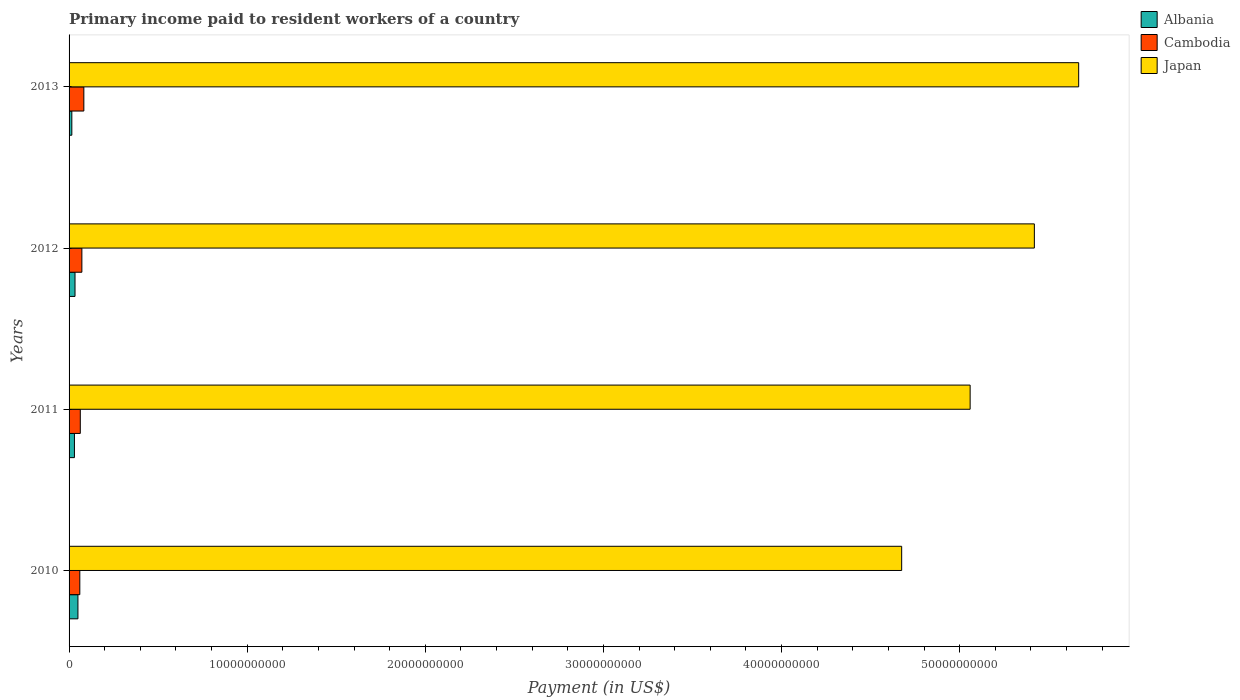Are the number of bars on each tick of the Y-axis equal?
Ensure brevity in your answer.  Yes. In how many cases, is the number of bars for a given year not equal to the number of legend labels?
Your answer should be very brief. 0. What is the amount paid to workers in Japan in 2013?
Provide a succinct answer. 5.67e+1. Across all years, what is the maximum amount paid to workers in Cambodia?
Keep it short and to the point. 8.29e+08. Across all years, what is the minimum amount paid to workers in Japan?
Make the answer very short. 4.67e+1. In which year was the amount paid to workers in Japan maximum?
Offer a very short reply. 2013. In which year was the amount paid to workers in Albania minimum?
Offer a very short reply. 2013. What is the total amount paid to workers in Albania in the graph?
Your answer should be compact. 1.29e+09. What is the difference between the amount paid to workers in Albania in 2010 and that in 2012?
Make the answer very short. 1.64e+08. What is the difference between the amount paid to workers in Japan in 2013 and the amount paid to workers in Albania in 2012?
Make the answer very short. 5.63e+1. What is the average amount paid to workers in Cambodia per year?
Ensure brevity in your answer.  6.95e+08. In the year 2012, what is the difference between the amount paid to workers in Albania and amount paid to workers in Cambodia?
Provide a succinct answer. -3.85e+08. What is the ratio of the amount paid to workers in Albania in 2011 to that in 2013?
Make the answer very short. 1.95. What is the difference between the highest and the second highest amount paid to workers in Cambodia?
Make the answer very short. 1.10e+08. What is the difference between the highest and the lowest amount paid to workers in Japan?
Make the answer very short. 9.94e+09. In how many years, is the amount paid to workers in Albania greater than the average amount paid to workers in Albania taken over all years?
Your response must be concise. 2. Is the sum of the amount paid to workers in Albania in 2010 and 2013 greater than the maximum amount paid to workers in Japan across all years?
Your answer should be very brief. No. What does the 3rd bar from the top in 2012 represents?
Offer a very short reply. Albania. What does the 3rd bar from the bottom in 2010 represents?
Keep it short and to the point. Japan. Is it the case that in every year, the sum of the amount paid to workers in Albania and amount paid to workers in Japan is greater than the amount paid to workers in Cambodia?
Keep it short and to the point. Yes. Are all the bars in the graph horizontal?
Give a very brief answer. Yes. How many years are there in the graph?
Provide a succinct answer. 4. What is the difference between two consecutive major ticks on the X-axis?
Provide a succinct answer. 1.00e+1. Are the values on the major ticks of X-axis written in scientific E-notation?
Your answer should be compact. No. Does the graph contain grids?
Provide a short and direct response. No. Where does the legend appear in the graph?
Make the answer very short. Top right. What is the title of the graph?
Provide a succinct answer. Primary income paid to resident workers of a country. What is the label or title of the X-axis?
Provide a short and direct response. Payment (in US$). What is the Payment (in US$) in Albania in 2010?
Ensure brevity in your answer.  4.98e+08. What is the Payment (in US$) of Cambodia in 2010?
Your answer should be very brief. 6.03e+08. What is the Payment (in US$) of Japan in 2010?
Provide a short and direct response. 4.67e+1. What is the Payment (in US$) of Albania in 2011?
Give a very brief answer. 3.01e+08. What is the Payment (in US$) of Cambodia in 2011?
Make the answer very short. 6.30e+08. What is the Payment (in US$) in Japan in 2011?
Provide a short and direct response. 5.06e+1. What is the Payment (in US$) of Albania in 2012?
Offer a terse response. 3.34e+08. What is the Payment (in US$) of Cambodia in 2012?
Offer a terse response. 7.19e+08. What is the Payment (in US$) of Japan in 2012?
Ensure brevity in your answer.  5.42e+1. What is the Payment (in US$) of Albania in 2013?
Keep it short and to the point. 1.55e+08. What is the Payment (in US$) in Cambodia in 2013?
Give a very brief answer. 8.29e+08. What is the Payment (in US$) in Japan in 2013?
Give a very brief answer. 5.67e+1. Across all years, what is the maximum Payment (in US$) of Albania?
Provide a succinct answer. 4.98e+08. Across all years, what is the maximum Payment (in US$) in Cambodia?
Your answer should be very brief. 8.29e+08. Across all years, what is the maximum Payment (in US$) in Japan?
Provide a short and direct response. 5.67e+1. Across all years, what is the minimum Payment (in US$) of Albania?
Ensure brevity in your answer.  1.55e+08. Across all years, what is the minimum Payment (in US$) of Cambodia?
Ensure brevity in your answer.  6.03e+08. Across all years, what is the minimum Payment (in US$) in Japan?
Give a very brief answer. 4.67e+1. What is the total Payment (in US$) in Albania in the graph?
Your response must be concise. 1.29e+09. What is the total Payment (in US$) of Cambodia in the graph?
Your response must be concise. 2.78e+09. What is the total Payment (in US$) in Japan in the graph?
Offer a terse response. 2.08e+11. What is the difference between the Payment (in US$) in Albania in 2010 and that in 2011?
Make the answer very short. 1.97e+08. What is the difference between the Payment (in US$) of Cambodia in 2010 and that in 2011?
Your response must be concise. -2.71e+07. What is the difference between the Payment (in US$) in Japan in 2010 and that in 2011?
Offer a terse response. -3.84e+09. What is the difference between the Payment (in US$) of Albania in 2010 and that in 2012?
Your response must be concise. 1.64e+08. What is the difference between the Payment (in US$) of Cambodia in 2010 and that in 2012?
Offer a terse response. -1.16e+08. What is the difference between the Payment (in US$) in Japan in 2010 and that in 2012?
Your response must be concise. -7.45e+09. What is the difference between the Payment (in US$) in Albania in 2010 and that in 2013?
Your answer should be compact. 3.43e+08. What is the difference between the Payment (in US$) in Cambodia in 2010 and that in 2013?
Your answer should be very brief. -2.26e+08. What is the difference between the Payment (in US$) of Japan in 2010 and that in 2013?
Offer a very short reply. -9.94e+09. What is the difference between the Payment (in US$) in Albania in 2011 and that in 2012?
Make the answer very short. -3.30e+07. What is the difference between the Payment (in US$) in Cambodia in 2011 and that in 2012?
Provide a short and direct response. -8.91e+07. What is the difference between the Payment (in US$) of Japan in 2011 and that in 2012?
Your response must be concise. -3.61e+09. What is the difference between the Payment (in US$) of Albania in 2011 and that in 2013?
Your answer should be very brief. 1.46e+08. What is the difference between the Payment (in US$) in Cambodia in 2011 and that in 2013?
Provide a succinct answer. -1.99e+08. What is the difference between the Payment (in US$) of Japan in 2011 and that in 2013?
Keep it short and to the point. -6.09e+09. What is the difference between the Payment (in US$) in Albania in 2012 and that in 2013?
Make the answer very short. 1.79e+08. What is the difference between the Payment (in US$) of Cambodia in 2012 and that in 2013?
Ensure brevity in your answer.  -1.10e+08. What is the difference between the Payment (in US$) in Japan in 2012 and that in 2013?
Your answer should be compact. -2.49e+09. What is the difference between the Payment (in US$) of Albania in 2010 and the Payment (in US$) of Cambodia in 2011?
Ensure brevity in your answer.  -1.32e+08. What is the difference between the Payment (in US$) in Albania in 2010 and the Payment (in US$) in Japan in 2011?
Make the answer very short. -5.01e+1. What is the difference between the Payment (in US$) in Cambodia in 2010 and the Payment (in US$) in Japan in 2011?
Offer a terse response. -5.00e+1. What is the difference between the Payment (in US$) of Albania in 2010 and the Payment (in US$) of Cambodia in 2012?
Make the answer very short. -2.21e+08. What is the difference between the Payment (in US$) in Albania in 2010 and the Payment (in US$) in Japan in 2012?
Give a very brief answer. -5.37e+1. What is the difference between the Payment (in US$) of Cambodia in 2010 and the Payment (in US$) of Japan in 2012?
Make the answer very short. -5.36e+1. What is the difference between the Payment (in US$) in Albania in 2010 and the Payment (in US$) in Cambodia in 2013?
Your response must be concise. -3.31e+08. What is the difference between the Payment (in US$) of Albania in 2010 and the Payment (in US$) of Japan in 2013?
Your answer should be compact. -5.62e+1. What is the difference between the Payment (in US$) in Cambodia in 2010 and the Payment (in US$) in Japan in 2013?
Your answer should be compact. -5.61e+1. What is the difference between the Payment (in US$) in Albania in 2011 and the Payment (in US$) in Cambodia in 2012?
Your answer should be compact. -4.18e+08. What is the difference between the Payment (in US$) in Albania in 2011 and the Payment (in US$) in Japan in 2012?
Ensure brevity in your answer.  -5.39e+1. What is the difference between the Payment (in US$) in Cambodia in 2011 and the Payment (in US$) in Japan in 2012?
Your response must be concise. -5.36e+1. What is the difference between the Payment (in US$) in Albania in 2011 and the Payment (in US$) in Cambodia in 2013?
Keep it short and to the point. -5.28e+08. What is the difference between the Payment (in US$) of Albania in 2011 and the Payment (in US$) of Japan in 2013?
Offer a very short reply. -5.64e+1. What is the difference between the Payment (in US$) of Cambodia in 2011 and the Payment (in US$) of Japan in 2013?
Your answer should be very brief. -5.61e+1. What is the difference between the Payment (in US$) in Albania in 2012 and the Payment (in US$) in Cambodia in 2013?
Your answer should be compact. -4.95e+08. What is the difference between the Payment (in US$) in Albania in 2012 and the Payment (in US$) in Japan in 2013?
Your answer should be compact. -5.63e+1. What is the difference between the Payment (in US$) of Cambodia in 2012 and the Payment (in US$) of Japan in 2013?
Offer a very short reply. -5.60e+1. What is the average Payment (in US$) of Albania per year?
Give a very brief answer. 3.22e+08. What is the average Payment (in US$) of Cambodia per year?
Make the answer very short. 6.95e+08. What is the average Payment (in US$) in Japan per year?
Offer a very short reply. 5.21e+1. In the year 2010, what is the difference between the Payment (in US$) in Albania and Payment (in US$) in Cambodia?
Your answer should be compact. -1.05e+08. In the year 2010, what is the difference between the Payment (in US$) in Albania and Payment (in US$) in Japan?
Offer a terse response. -4.62e+1. In the year 2010, what is the difference between the Payment (in US$) in Cambodia and Payment (in US$) in Japan?
Give a very brief answer. -4.61e+1. In the year 2011, what is the difference between the Payment (in US$) in Albania and Payment (in US$) in Cambodia?
Your response must be concise. -3.29e+08. In the year 2011, what is the difference between the Payment (in US$) in Albania and Payment (in US$) in Japan?
Offer a terse response. -5.03e+1. In the year 2011, what is the difference between the Payment (in US$) of Cambodia and Payment (in US$) of Japan?
Your answer should be very brief. -5.00e+1. In the year 2012, what is the difference between the Payment (in US$) of Albania and Payment (in US$) of Cambodia?
Your answer should be compact. -3.85e+08. In the year 2012, what is the difference between the Payment (in US$) in Albania and Payment (in US$) in Japan?
Give a very brief answer. -5.39e+1. In the year 2012, what is the difference between the Payment (in US$) of Cambodia and Payment (in US$) of Japan?
Your answer should be very brief. -5.35e+1. In the year 2013, what is the difference between the Payment (in US$) of Albania and Payment (in US$) of Cambodia?
Your answer should be very brief. -6.75e+08. In the year 2013, what is the difference between the Payment (in US$) of Albania and Payment (in US$) of Japan?
Provide a succinct answer. -5.65e+1. In the year 2013, what is the difference between the Payment (in US$) in Cambodia and Payment (in US$) in Japan?
Your answer should be very brief. -5.59e+1. What is the ratio of the Payment (in US$) of Albania in 2010 to that in 2011?
Your answer should be very brief. 1.65. What is the ratio of the Payment (in US$) of Cambodia in 2010 to that in 2011?
Your answer should be compact. 0.96. What is the ratio of the Payment (in US$) in Japan in 2010 to that in 2011?
Your answer should be very brief. 0.92. What is the ratio of the Payment (in US$) of Albania in 2010 to that in 2012?
Make the answer very short. 1.49. What is the ratio of the Payment (in US$) in Cambodia in 2010 to that in 2012?
Provide a succinct answer. 0.84. What is the ratio of the Payment (in US$) in Japan in 2010 to that in 2012?
Offer a very short reply. 0.86. What is the ratio of the Payment (in US$) in Albania in 2010 to that in 2013?
Give a very brief answer. 3.22. What is the ratio of the Payment (in US$) of Cambodia in 2010 to that in 2013?
Provide a succinct answer. 0.73. What is the ratio of the Payment (in US$) of Japan in 2010 to that in 2013?
Provide a short and direct response. 0.82. What is the ratio of the Payment (in US$) of Albania in 2011 to that in 2012?
Give a very brief answer. 0.9. What is the ratio of the Payment (in US$) of Cambodia in 2011 to that in 2012?
Your answer should be very brief. 0.88. What is the ratio of the Payment (in US$) of Japan in 2011 to that in 2012?
Your answer should be compact. 0.93. What is the ratio of the Payment (in US$) of Albania in 2011 to that in 2013?
Give a very brief answer. 1.95. What is the ratio of the Payment (in US$) of Cambodia in 2011 to that in 2013?
Make the answer very short. 0.76. What is the ratio of the Payment (in US$) of Japan in 2011 to that in 2013?
Keep it short and to the point. 0.89. What is the ratio of the Payment (in US$) in Albania in 2012 to that in 2013?
Make the answer very short. 2.16. What is the ratio of the Payment (in US$) in Cambodia in 2012 to that in 2013?
Keep it short and to the point. 0.87. What is the ratio of the Payment (in US$) of Japan in 2012 to that in 2013?
Make the answer very short. 0.96. What is the difference between the highest and the second highest Payment (in US$) in Albania?
Make the answer very short. 1.64e+08. What is the difference between the highest and the second highest Payment (in US$) of Cambodia?
Offer a very short reply. 1.10e+08. What is the difference between the highest and the second highest Payment (in US$) in Japan?
Ensure brevity in your answer.  2.49e+09. What is the difference between the highest and the lowest Payment (in US$) in Albania?
Offer a terse response. 3.43e+08. What is the difference between the highest and the lowest Payment (in US$) in Cambodia?
Give a very brief answer. 2.26e+08. What is the difference between the highest and the lowest Payment (in US$) in Japan?
Give a very brief answer. 9.94e+09. 